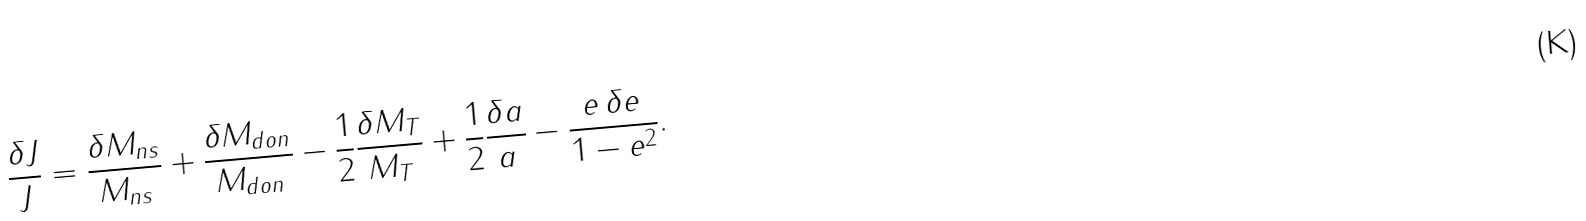<formula> <loc_0><loc_0><loc_500><loc_500>\frac { \delta J } { J } = \frac { \delta M _ { n s } } { M _ { n s } } + \frac { \delta M _ { d o n } } { M _ { d o n } } - \frac { 1 } { 2 } \frac { \delta M _ { T } } { M _ { T } } + \frac { 1 } { 2 } \frac { \delta a } { a } - \frac { e \, \delta e } { 1 - e ^ { 2 } } .</formula> 